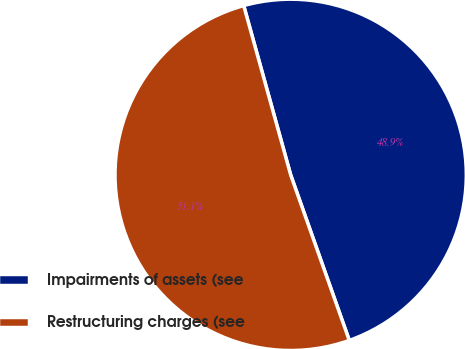<chart> <loc_0><loc_0><loc_500><loc_500><pie_chart><fcel>Impairments of assets (see<fcel>Restructuring charges (see<nl><fcel>48.89%<fcel>51.11%<nl></chart> 